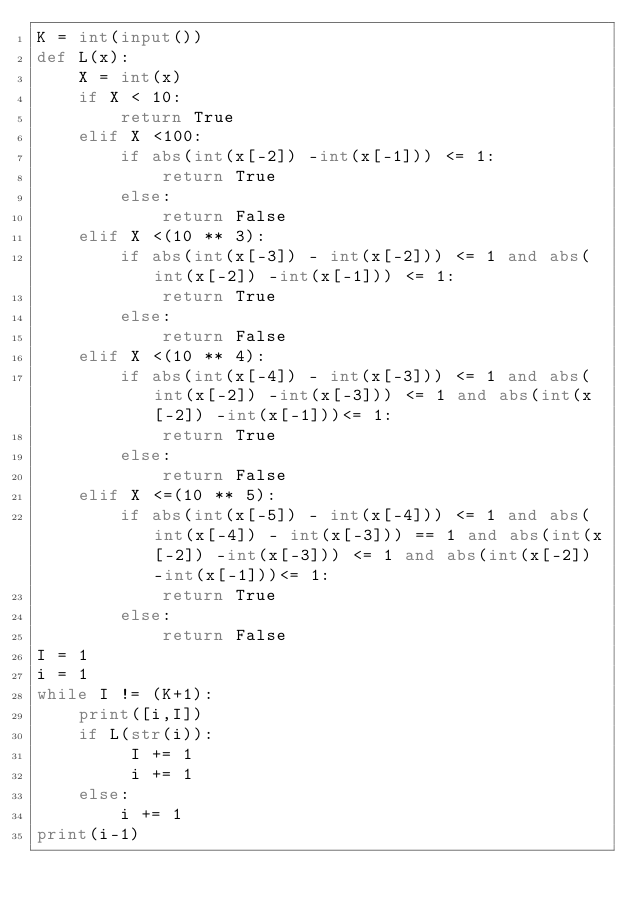Convert code to text. <code><loc_0><loc_0><loc_500><loc_500><_Python_>K = int(input())
def L(x):
    X = int(x)
    if X < 10:
        return True
    elif X <100:
        if abs(int(x[-2]) -int(x[-1])) <= 1:
            return True
        else:
            return False
    elif X <(10 ** 3):
        if abs(int(x[-3]) - int(x[-2])) <= 1 and abs(int(x[-2]) -int(x[-1])) <= 1:
            return True
        else:
            return False
    elif X <(10 ** 4):
        if abs(int(x[-4]) - int(x[-3])) <= 1 and abs(int(x[-2]) -int(x[-3])) <= 1 and abs(int(x[-2]) -int(x[-1]))<= 1:
            return True
        else:
            return False
    elif X <=(10 ** 5):
        if abs(int(x[-5]) - int(x[-4])) <= 1 and abs(int(x[-4]) - int(x[-3])) == 1 and abs(int(x[-2]) -int(x[-3])) <= 1 and abs(int(x[-2]) -int(x[-1]))<= 1:
            return True
        else:
            return False
I = 1
i = 1
while I != (K+1):
    print([i,I])
    if L(str(i)):
         I += 1
         i += 1
    else:
        i += 1
print(i-1)</code> 